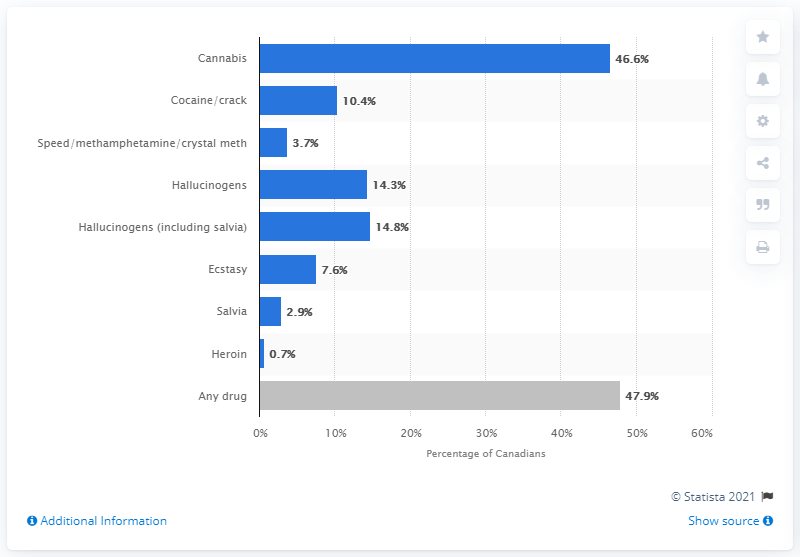List a handful of essential elements in this visual. Cannabis is the most commonly used illicit drug in Canada. Approximately 14% of the categories consist of Hallucinogens and Hallucinogens (including salvia). Which drug is considered to have the highest value, excluding any drug? Cannabis. 